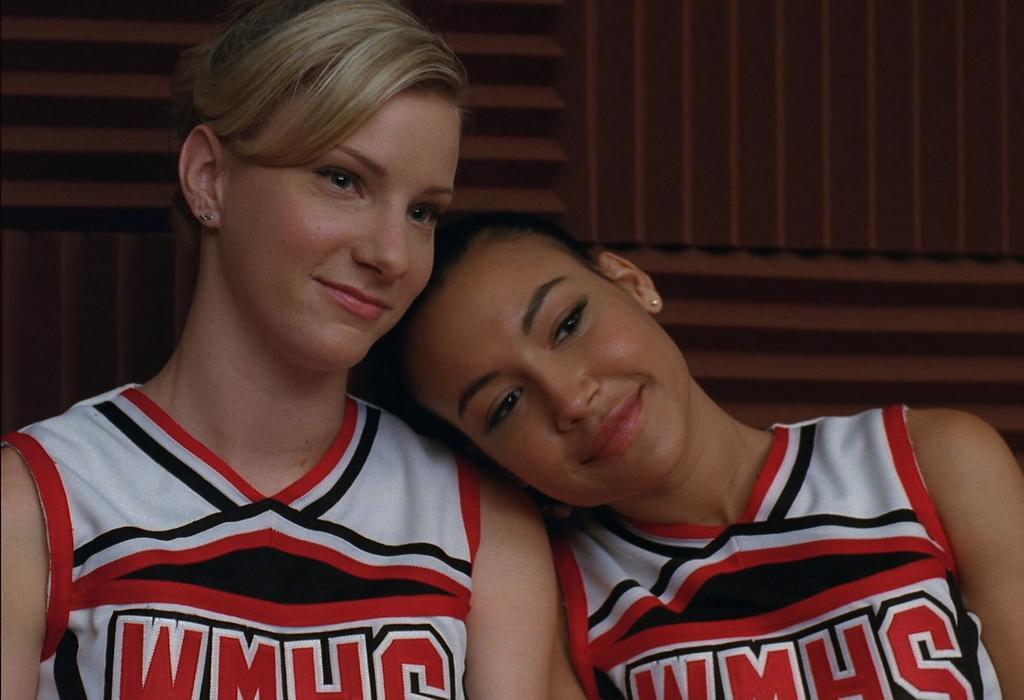Describe this image in one or two sentences. This image is taken indoors. In the background there is a wall. In this image there are two women. 